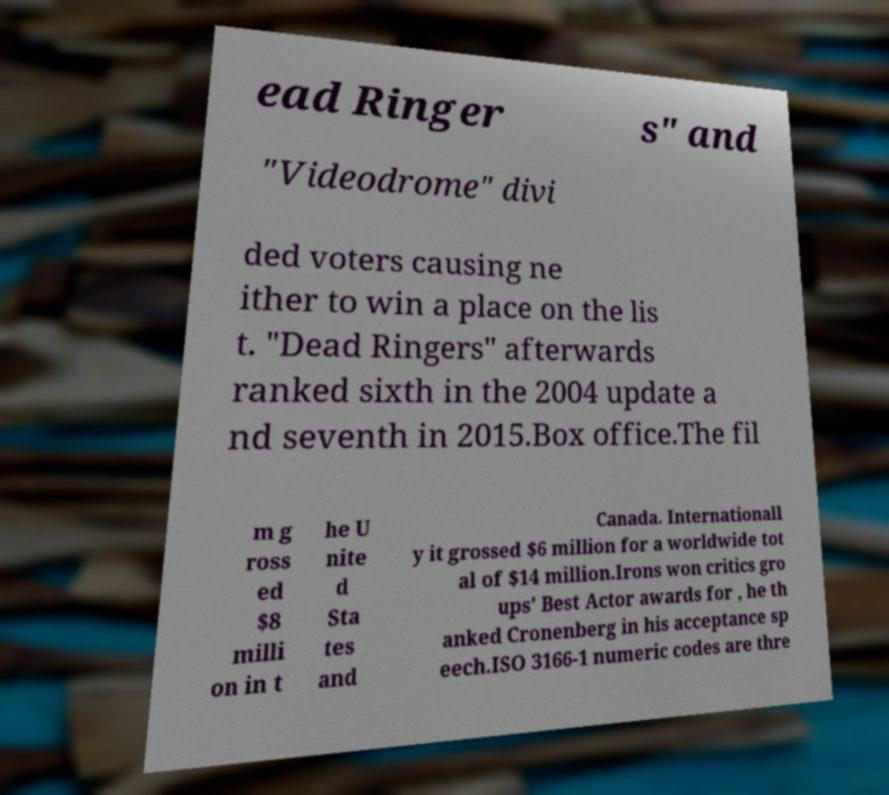Can you accurately transcribe the text from the provided image for me? ead Ringer s" and "Videodrome" divi ded voters causing ne ither to win a place on the lis t. "Dead Ringers" afterwards ranked sixth in the 2004 update a nd seventh in 2015.Box office.The fil m g ross ed $8 milli on in t he U nite d Sta tes and Canada. Internationall y it grossed $6 million for a worldwide tot al of $14 million.Irons won critics gro ups' Best Actor awards for , he th anked Cronenberg in his acceptance sp eech.ISO 3166-1 numeric codes are thre 